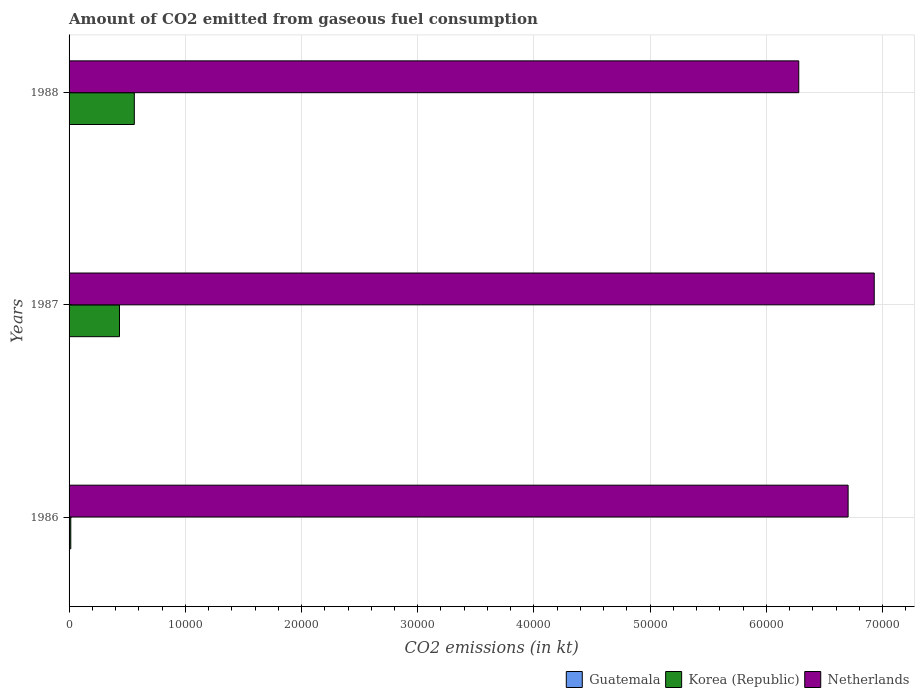How many different coloured bars are there?
Your response must be concise. 3. Are the number of bars on each tick of the Y-axis equal?
Offer a very short reply. Yes. How many bars are there on the 3rd tick from the bottom?
Provide a succinct answer. 3. What is the label of the 2nd group of bars from the top?
Provide a short and direct response. 1987. What is the amount of CO2 emitted in Guatemala in 1988?
Your answer should be compact. 25.67. Across all years, what is the maximum amount of CO2 emitted in Netherlands?
Give a very brief answer. 6.93e+04. Across all years, what is the minimum amount of CO2 emitted in Korea (Republic)?
Provide a short and direct response. 146.68. In which year was the amount of CO2 emitted in Guatemala maximum?
Offer a very short reply. 1987. What is the total amount of CO2 emitted in Netherlands in the graph?
Provide a succinct answer. 1.99e+05. What is the difference between the amount of CO2 emitted in Korea (Republic) in 1986 and that in 1988?
Your answer should be compact. -5467.5. What is the difference between the amount of CO2 emitted in Korea (Republic) in 1987 and the amount of CO2 emitted in Netherlands in 1986?
Your answer should be compact. -6.27e+04. What is the average amount of CO2 emitted in Korea (Republic) per year?
Provide a succinct answer. 3366.31. In the year 1987, what is the difference between the amount of CO2 emitted in Guatemala and amount of CO2 emitted in Netherlands?
Your answer should be very brief. -6.92e+04. What is the ratio of the amount of CO2 emitted in Guatemala in 1987 to that in 1988?
Provide a succinct answer. 1.43. Is the amount of CO2 emitted in Korea (Republic) in 1987 less than that in 1988?
Offer a very short reply. Yes. Is the difference between the amount of CO2 emitted in Guatemala in 1986 and 1988 greater than the difference between the amount of CO2 emitted in Netherlands in 1986 and 1988?
Your response must be concise. No. What is the difference between the highest and the second highest amount of CO2 emitted in Guatemala?
Provide a succinct answer. 11. What is the difference between the highest and the lowest amount of CO2 emitted in Korea (Republic)?
Make the answer very short. 5467.5. In how many years, is the amount of CO2 emitted in Korea (Republic) greater than the average amount of CO2 emitted in Korea (Republic) taken over all years?
Provide a short and direct response. 2. Is the sum of the amount of CO2 emitted in Guatemala in 1987 and 1988 greater than the maximum amount of CO2 emitted in Korea (Republic) across all years?
Offer a terse response. No. What does the 3rd bar from the top in 1988 represents?
Make the answer very short. Guatemala. What does the 1st bar from the bottom in 1987 represents?
Offer a terse response. Guatemala. Is it the case that in every year, the sum of the amount of CO2 emitted in Guatemala and amount of CO2 emitted in Netherlands is greater than the amount of CO2 emitted in Korea (Republic)?
Offer a very short reply. Yes. How many bars are there?
Provide a short and direct response. 9. How many years are there in the graph?
Your response must be concise. 3. Does the graph contain any zero values?
Your answer should be compact. No. What is the title of the graph?
Make the answer very short. Amount of CO2 emitted from gaseous fuel consumption. What is the label or title of the X-axis?
Your response must be concise. CO2 emissions (in kt). What is the label or title of the Y-axis?
Provide a succinct answer. Years. What is the CO2 emissions (in kt) of Guatemala in 1986?
Provide a succinct answer. 22. What is the CO2 emissions (in kt) of Korea (Republic) in 1986?
Offer a very short reply. 146.68. What is the CO2 emissions (in kt) in Netherlands in 1986?
Offer a very short reply. 6.70e+04. What is the CO2 emissions (in kt) of Guatemala in 1987?
Ensure brevity in your answer.  36.67. What is the CO2 emissions (in kt) in Korea (Republic) in 1987?
Make the answer very short. 4338.06. What is the CO2 emissions (in kt) in Netherlands in 1987?
Give a very brief answer. 6.93e+04. What is the CO2 emissions (in kt) in Guatemala in 1988?
Offer a very short reply. 25.67. What is the CO2 emissions (in kt) in Korea (Republic) in 1988?
Your answer should be compact. 5614.18. What is the CO2 emissions (in kt) of Netherlands in 1988?
Your response must be concise. 6.28e+04. Across all years, what is the maximum CO2 emissions (in kt) in Guatemala?
Your answer should be compact. 36.67. Across all years, what is the maximum CO2 emissions (in kt) in Korea (Republic)?
Provide a short and direct response. 5614.18. Across all years, what is the maximum CO2 emissions (in kt) of Netherlands?
Your answer should be very brief. 6.93e+04. Across all years, what is the minimum CO2 emissions (in kt) in Guatemala?
Offer a terse response. 22. Across all years, what is the minimum CO2 emissions (in kt) in Korea (Republic)?
Offer a terse response. 146.68. Across all years, what is the minimum CO2 emissions (in kt) of Netherlands?
Ensure brevity in your answer.  6.28e+04. What is the total CO2 emissions (in kt) in Guatemala in the graph?
Provide a succinct answer. 84.34. What is the total CO2 emissions (in kt) in Korea (Republic) in the graph?
Ensure brevity in your answer.  1.01e+04. What is the total CO2 emissions (in kt) of Netherlands in the graph?
Provide a succinct answer. 1.99e+05. What is the difference between the CO2 emissions (in kt) in Guatemala in 1986 and that in 1987?
Your response must be concise. -14.67. What is the difference between the CO2 emissions (in kt) in Korea (Republic) in 1986 and that in 1987?
Provide a succinct answer. -4191.38. What is the difference between the CO2 emissions (in kt) in Netherlands in 1986 and that in 1987?
Make the answer very short. -2247.87. What is the difference between the CO2 emissions (in kt) of Guatemala in 1986 and that in 1988?
Keep it short and to the point. -3.67. What is the difference between the CO2 emissions (in kt) of Korea (Republic) in 1986 and that in 1988?
Your answer should be very brief. -5467.5. What is the difference between the CO2 emissions (in kt) of Netherlands in 1986 and that in 1988?
Your answer should be compact. 4246.39. What is the difference between the CO2 emissions (in kt) of Guatemala in 1987 and that in 1988?
Keep it short and to the point. 11. What is the difference between the CO2 emissions (in kt) of Korea (Republic) in 1987 and that in 1988?
Your answer should be very brief. -1276.12. What is the difference between the CO2 emissions (in kt) in Netherlands in 1987 and that in 1988?
Provide a succinct answer. 6494.26. What is the difference between the CO2 emissions (in kt) of Guatemala in 1986 and the CO2 emissions (in kt) of Korea (Republic) in 1987?
Your response must be concise. -4316.06. What is the difference between the CO2 emissions (in kt) of Guatemala in 1986 and the CO2 emissions (in kt) of Netherlands in 1987?
Make the answer very short. -6.93e+04. What is the difference between the CO2 emissions (in kt) of Korea (Republic) in 1986 and the CO2 emissions (in kt) of Netherlands in 1987?
Provide a short and direct response. -6.91e+04. What is the difference between the CO2 emissions (in kt) in Guatemala in 1986 and the CO2 emissions (in kt) in Korea (Republic) in 1988?
Provide a succinct answer. -5592.18. What is the difference between the CO2 emissions (in kt) in Guatemala in 1986 and the CO2 emissions (in kt) in Netherlands in 1988?
Offer a very short reply. -6.28e+04. What is the difference between the CO2 emissions (in kt) of Korea (Republic) in 1986 and the CO2 emissions (in kt) of Netherlands in 1988?
Provide a short and direct response. -6.26e+04. What is the difference between the CO2 emissions (in kt) in Guatemala in 1987 and the CO2 emissions (in kt) in Korea (Republic) in 1988?
Give a very brief answer. -5577.51. What is the difference between the CO2 emissions (in kt) in Guatemala in 1987 and the CO2 emissions (in kt) in Netherlands in 1988?
Give a very brief answer. -6.27e+04. What is the difference between the CO2 emissions (in kt) in Korea (Republic) in 1987 and the CO2 emissions (in kt) in Netherlands in 1988?
Offer a terse response. -5.84e+04. What is the average CO2 emissions (in kt) in Guatemala per year?
Ensure brevity in your answer.  28.11. What is the average CO2 emissions (in kt) of Korea (Republic) per year?
Ensure brevity in your answer.  3366.31. What is the average CO2 emissions (in kt) of Netherlands per year?
Provide a succinct answer. 6.64e+04. In the year 1986, what is the difference between the CO2 emissions (in kt) of Guatemala and CO2 emissions (in kt) of Korea (Republic)?
Your answer should be compact. -124.68. In the year 1986, what is the difference between the CO2 emissions (in kt) in Guatemala and CO2 emissions (in kt) in Netherlands?
Your answer should be compact. -6.70e+04. In the year 1986, what is the difference between the CO2 emissions (in kt) in Korea (Republic) and CO2 emissions (in kt) in Netherlands?
Your response must be concise. -6.69e+04. In the year 1987, what is the difference between the CO2 emissions (in kt) of Guatemala and CO2 emissions (in kt) of Korea (Republic)?
Your response must be concise. -4301.39. In the year 1987, what is the difference between the CO2 emissions (in kt) of Guatemala and CO2 emissions (in kt) of Netherlands?
Provide a short and direct response. -6.92e+04. In the year 1987, what is the difference between the CO2 emissions (in kt) in Korea (Republic) and CO2 emissions (in kt) in Netherlands?
Ensure brevity in your answer.  -6.49e+04. In the year 1988, what is the difference between the CO2 emissions (in kt) in Guatemala and CO2 emissions (in kt) in Korea (Republic)?
Give a very brief answer. -5588.51. In the year 1988, what is the difference between the CO2 emissions (in kt) in Guatemala and CO2 emissions (in kt) in Netherlands?
Your answer should be very brief. -6.28e+04. In the year 1988, what is the difference between the CO2 emissions (in kt) in Korea (Republic) and CO2 emissions (in kt) in Netherlands?
Keep it short and to the point. -5.72e+04. What is the ratio of the CO2 emissions (in kt) of Korea (Republic) in 1986 to that in 1987?
Make the answer very short. 0.03. What is the ratio of the CO2 emissions (in kt) of Netherlands in 1986 to that in 1987?
Keep it short and to the point. 0.97. What is the ratio of the CO2 emissions (in kt) of Guatemala in 1986 to that in 1988?
Provide a succinct answer. 0.86. What is the ratio of the CO2 emissions (in kt) of Korea (Republic) in 1986 to that in 1988?
Keep it short and to the point. 0.03. What is the ratio of the CO2 emissions (in kt) in Netherlands in 1986 to that in 1988?
Your answer should be compact. 1.07. What is the ratio of the CO2 emissions (in kt) in Guatemala in 1987 to that in 1988?
Ensure brevity in your answer.  1.43. What is the ratio of the CO2 emissions (in kt) in Korea (Republic) in 1987 to that in 1988?
Offer a very short reply. 0.77. What is the ratio of the CO2 emissions (in kt) in Netherlands in 1987 to that in 1988?
Provide a succinct answer. 1.1. What is the difference between the highest and the second highest CO2 emissions (in kt) in Guatemala?
Offer a very short reply. 11. What is the difference between the highest and the second highest CO2 emissions (in kt) in Korea (Republic)?
Offer a terse response. 1276.12. What is the difference between the highest and the second highest CO2 emissions (in kt) in Netherlands?
Ensure brevity in your answer.  2247.87. What is the difference between the highest and the lowest CO2 emissions (in kt) of Guatemala?
Provide a short and direct response. 14.67. What is the difference between the highest and the lowest CO2 emissions (in kt) in Korea (Republic)?
Make the answer very short. 5467.5. What is the difference between the highest and the lowest CO2 emissions (in kt) of Netherlands?
Make the answer very short. 6494.26. 